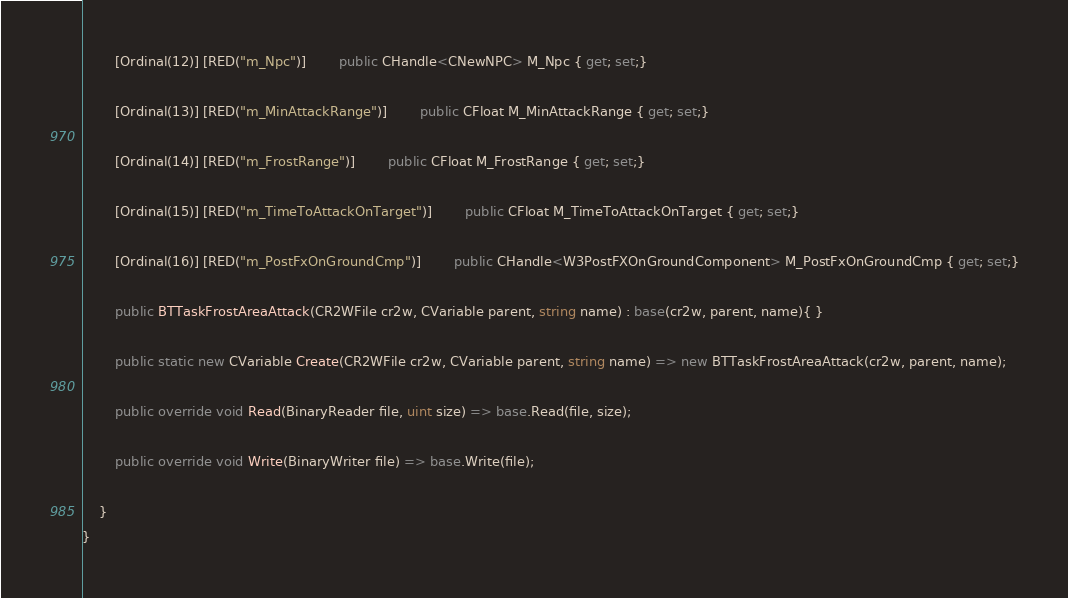Convert code to text. <code><loc_0><loc_0><loc_500><loc_500><_C#_>		[Ordinal(12)] [RED("m_Npc")] 		public CHandle<CNewNPC> M_Npc { get; set;}

		[Ordinal(13)] [RED("m_MinAttackRange")] 		public CFloat M_MinAttackRange { get; set;}

		[Ordinal(14)] [RED("m_FrostRange")] 		public CFloat M_FrostRange { get; set;}

		[Ordinal(15)] [RED("m_TimeToAttackOnTarget")] 		public CFloat M_TimeToAttackOnTarget { get; set;}

		[Ordinal(16)] [RED("m_PostFxOnGroundCmp")] 		public CHandle<W3PostFXOnGroundComponent> M_PostFxOnGroundCmp { get; set;}

		public BTTaskFrostAreaAttack(CR2WFile cr2w, CVariable parent, string name) : base(cr2w, parent, name){ }

		public static new CVariable Create(CR2WFile cr2w, CVariable parent, string name) => new BTTaskFrostAreaAttack(cr2w, parent, name);

		public override void Read(BinaryReader file, uint size) => base.Read(file, size);

		public override void Write(BinaryWriter file) => base.Write(file);

	}
}</code> 